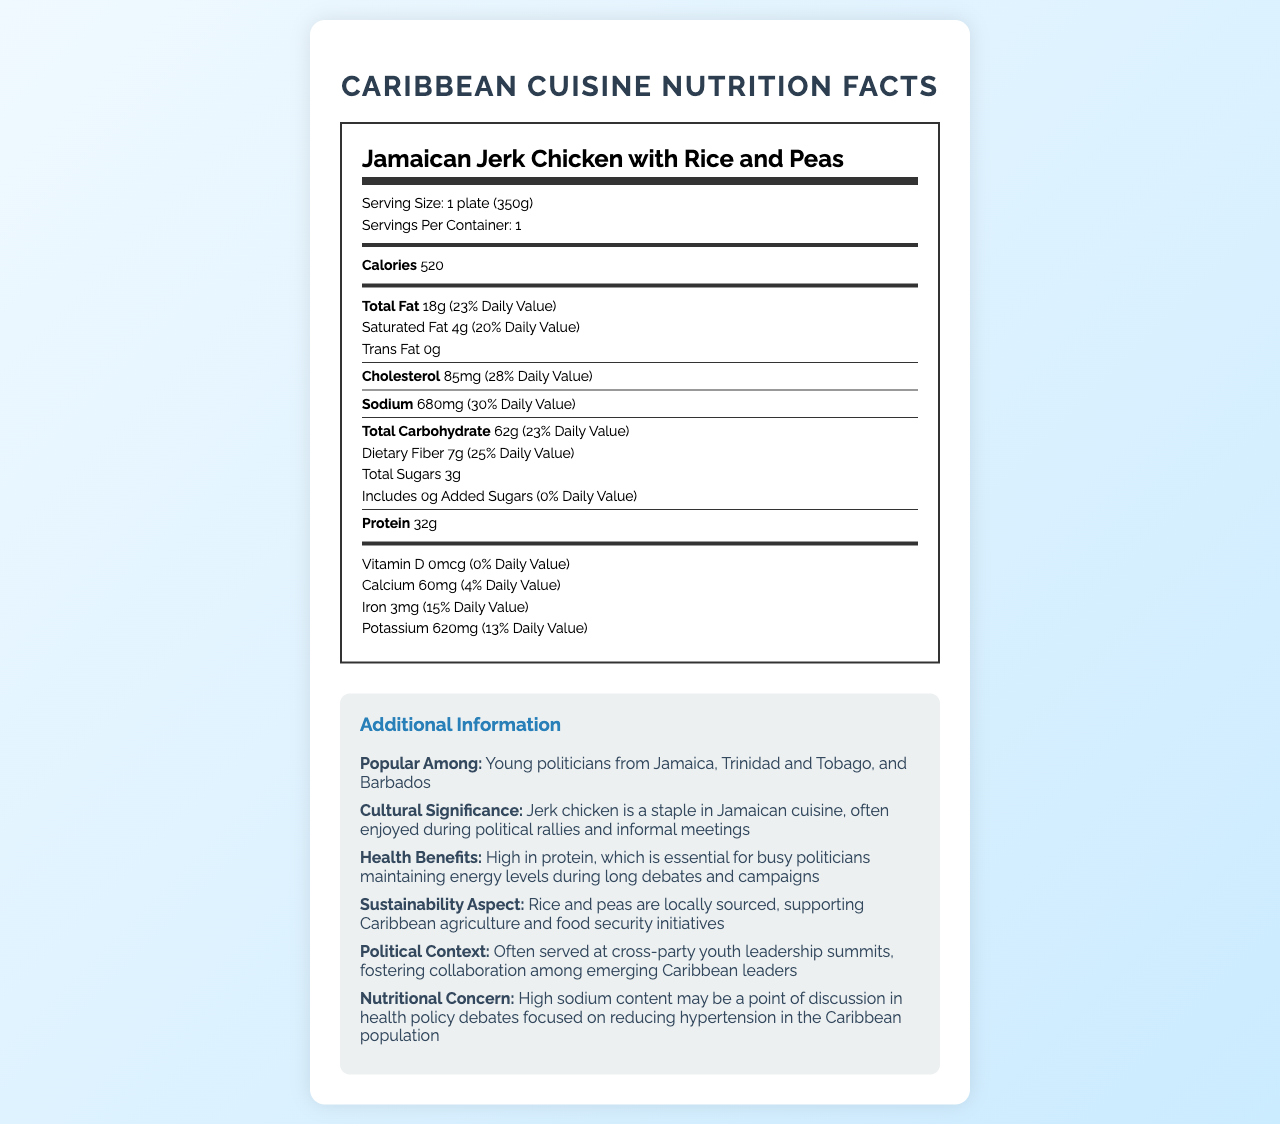what is the serving size of the dish? The serving size is mentioned at the top of the document under the dish name "Jamaican Jerk Chicken with Rice and Peas."
Answer: 1 plate (350g) how many calories are in one serving? The calorie content is listed in bold under the section for calories.
Answer: 520 what is the daily value percentage for total fat? The daily value percentage for total fat is given alongside the total fat content.
Answer: 23% how much protein does the dish contain? The protein content is listed in the nutrition facts section.
Answer: 32g what are the health benefits of Jamaican Jerk Chicken with Rice and Peas? This information is provided in the "Additional Information" section under "Health Benefits."
Answer: High in protein, which is essential for busy politicians maintaining energy levels during long debates and campaigns which mineral is present in the largest amount? A. Calcium B. Iron C. Potassium The potassium content is 620mg, which is higher than both calcium (60mg) and iron (3mg).
Answer: C. Potassium how much sodium does one serving contain? A. 85mg B. 680mg C. 620mg The sodium content is indicated in the nutrition facts under the "Sodium" section.
Answer: B. 680mg is there any trans fat in this dish? The document specifies "Trans Fat 0g," indicating there is no trans fat.
Answer: No does the dish contain added sugars? It explicitly states "Includes 0g Added Sugars" in the nutrition label.
Answer: No does the dish have any vitamin D? The nutrition label states "Vitamin D 0mcg," meaning there is no vitamin D in the dish.
Answer: No summarize the main idea of the nutrition facts document. The document combines nutritional data of the dish with its relevance in cultural, political, and health contexts.
Answer: The document provides nutritional information about Jamaican Jerk Chicken with Rice and Peas, including calorie content, macronutrient breakdown, and micronutrient amounts. It highlights the health benefits for young politicians, the cultural and political significance of the dish, as well as its sustainability aspects. The dish is popular among young politicians from several Caribbean countries and is often consumed during political events. However, it also points out a nutritional concern with high sodium content. who is the dish popular among? This information is listed under the "Additional Information" section, detailing the popularity of the dish.
Answer: Young politicians from Jamaica, Trinidad and Tobago, and Barbados how does the dish support sustainability? This sustainability aspect is mentioned in the additional information section.
Answer: Rice and peas are locally sourced, supporting Caribbean agriculture and food security initiatives what is the main nutritional concern mentioned about the dish? The additional information section points out that the high sodium content may be a point of discussion in health policy debates.
Answer: High sodium content where is this dish commonly served? This information is provided under the "Political Context" section in the additional information.
Answer: Often served at cross-party youth leadership summits how much dietary fiber does one serving provide? The dietary fiber content is listed in the nutrition facts section.
Answer: 7g is this dish traditionally served with plantains? The document does not provide any details about serving the dish with plantains.
Answer: Not enough information 